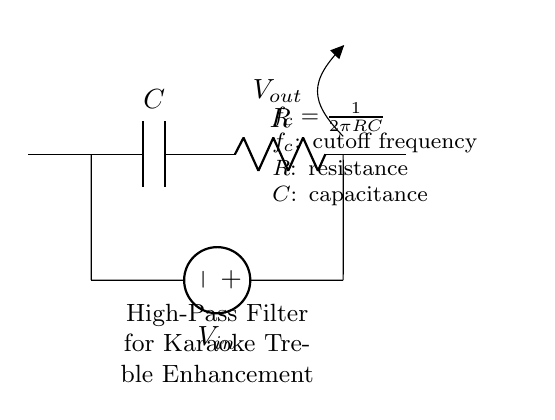What type of filter is represented in the circuit? The circuit is a high-pass filter, as indicated by the arrangement of the capacitor and resistor which allow high-frequency signals to pass while attenuating low-frequency signals.
Answer: high-pass filter What function does the capacitor serve in this circuit? The capacitor blocks low-frequency signals while allowing high-frequency signals to pass through. This characteristic is essential for enhancing treble frequencies in the audio application.
Answer: blocks low-frequency signals What is the cutoff frequency formula provided in the circuit? The formula for cutoff frequency is given as f_c = 1/(2πRC), where R is resistance and C is capacitance. This relationship indicates how the cutoff frequency depends on the values of these components.
Answer: f_c = 1/(2πRC) If the resistance is 10k ohms and capacitance is 10uF, what is the cutoff frequency? Using the formula f_c = 1/(2πRC), substituting R with 10k ohms and C with 10uF gives a cutoff frequency of approximately 1591 Hz, calculated as f_c = 1/(2π(10000)(10e-6)).
Answer: 1591 Hz What is the role of the resistor in this high-pass filter circuit? The resistor, in conjunction with the capacitor, sets the cutoff frequency of the filter, determining the range of frequencies that can bypass the filter and enhancing specific treble frequencies necessary for clarity in audio.
Answer: sets cutoff frequency What is the voltage source labeled as in the circuit? The voltage source is labeled as V_in, which represents the input voltage being applied to the circuit.
Answer: V_in 